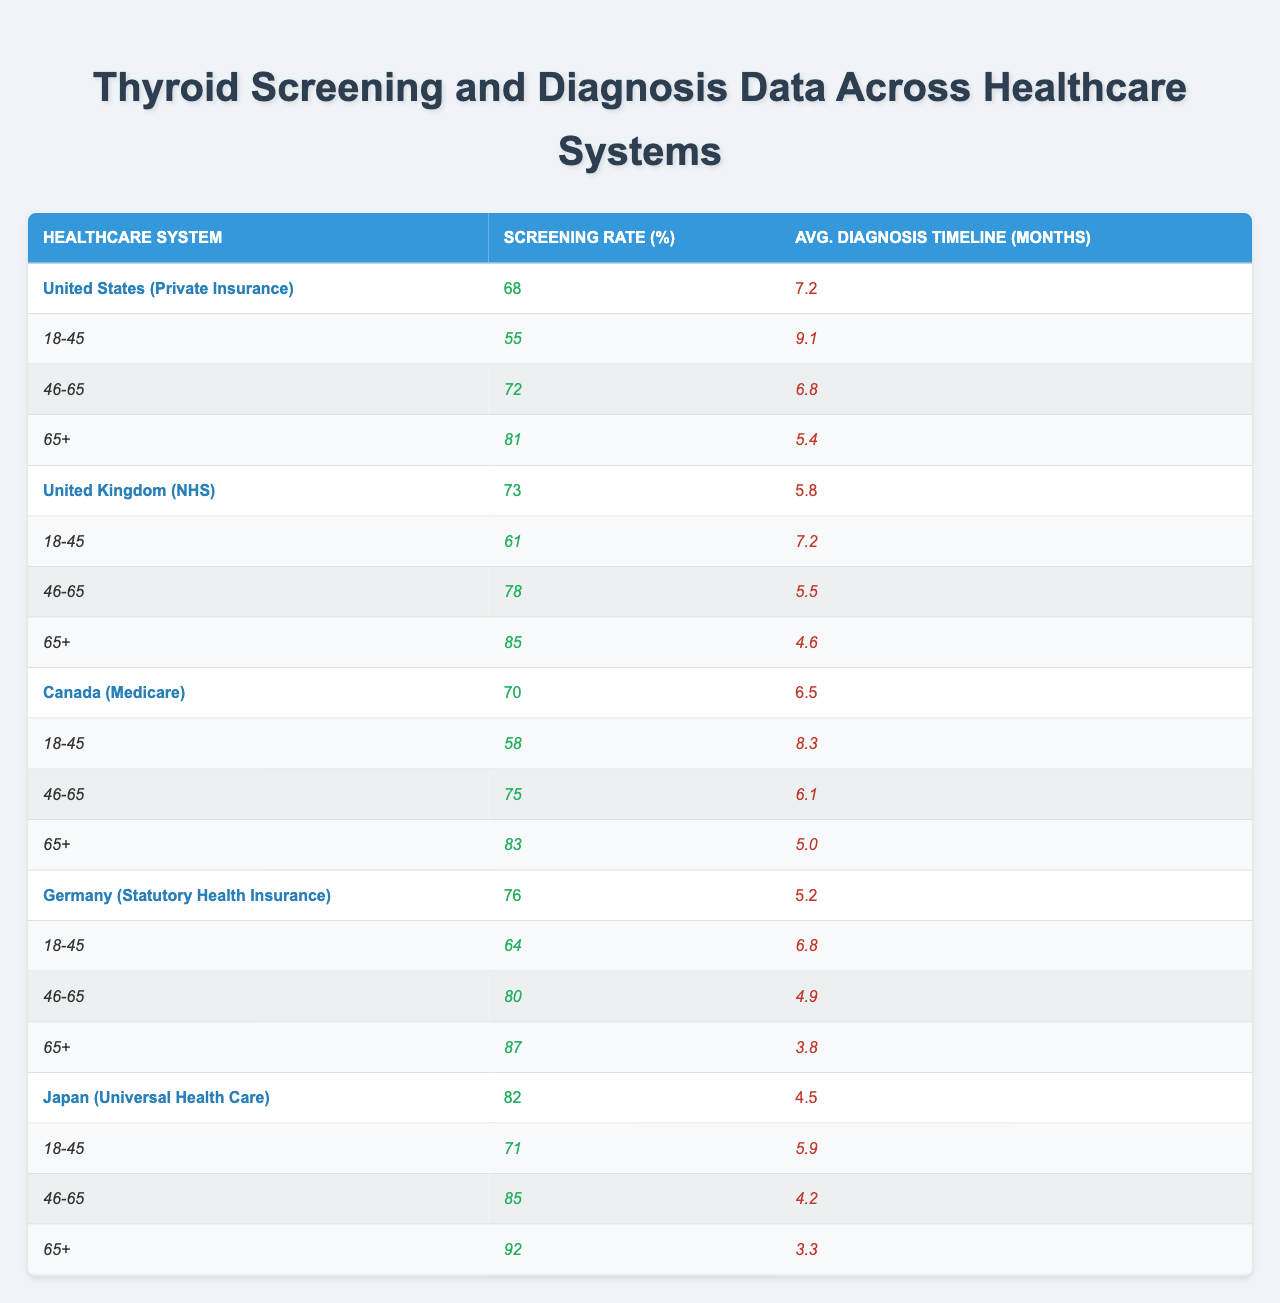What is the screening rate in the United Kingdom? The table shows that the screening rate for the United Kingdom (NHS) is 73%.
Answer: 73% Which healthcare system has the lowest average diagnosis timeline? According to the data, Japan (Universal Health Care) has the lowest average diagnosis timeline of 4.5 months.
Answer: 4.5 months What is the screening rate for the age group 46-65 in Germany? The table indicates that the screening rate for the age group 46-65 in Germany is 80%.
Answer: 80% Which country has a higher screening rate: Canada or the United States? The screening rates are 70% for Canada and 68% for the United States. Thus, Canada has a higher screening rate.
Answer: Canada What is the average diagnosis timeline for the age group 65+ in the United States? The average diagnosis timeline for the age group 65+ in the United States is 5.4 months.
Answer: 5.4 months What is the overall average screening rate across all healthcare systems? To find the overall average screening rate, sum the screening rates (68 + 73 + 70 + 76 + 82) = 369, then divide by the number of systems (5). This gives an average screening rate of 369/5 = 73.8%.
Answer: 73.8% Is the screening rate for the age group 18-45 in Japan greater than 70%? In Japan, the screening rate for the age group 18-45 is 71%, which is greater than 70%.
Answer: Yes Which healthcare system has the highest screening rate for the age group 65+? The highest screening rate for the age group 65+ is seen in Japan, which is 92%.
Answer: 92% What is the difference in average diagnosis timelines between Germany and the United Kingdom? Germany’s average diagnosis timeline is 5.2 months and the United Kingdom’s is 5.8 months. The difference is 5.8 - 5.2 = 0.6 months.
Answer: 0.6 months Do all age groups in the United Kingdom have screening rates above 60%? The United Kingdom has the following screening rates: 61% for age 18-45, 78% for age 46-65, and 85% for age 65+. All groups are above 60%.
Answer: Yes 